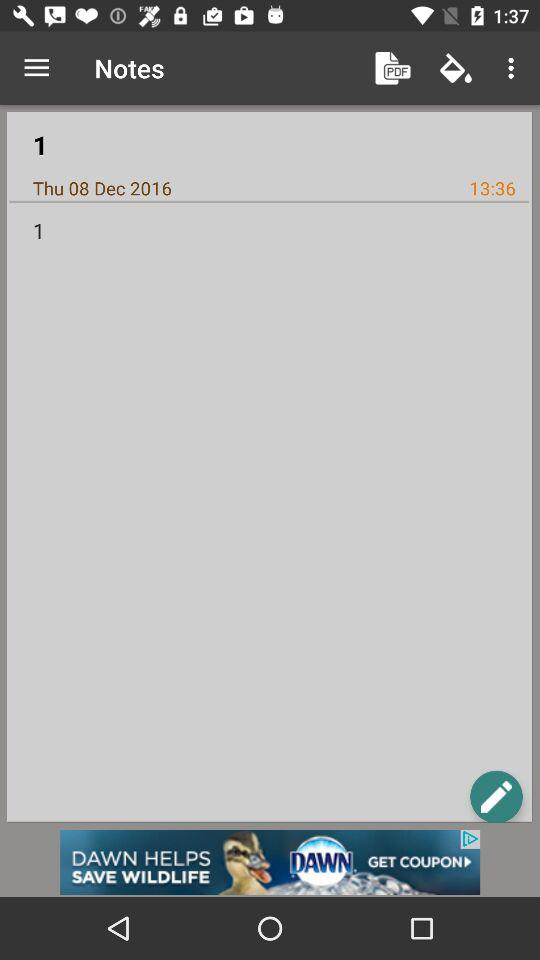What was the day when the note was saved? The day when the note was saved is Thursday. 